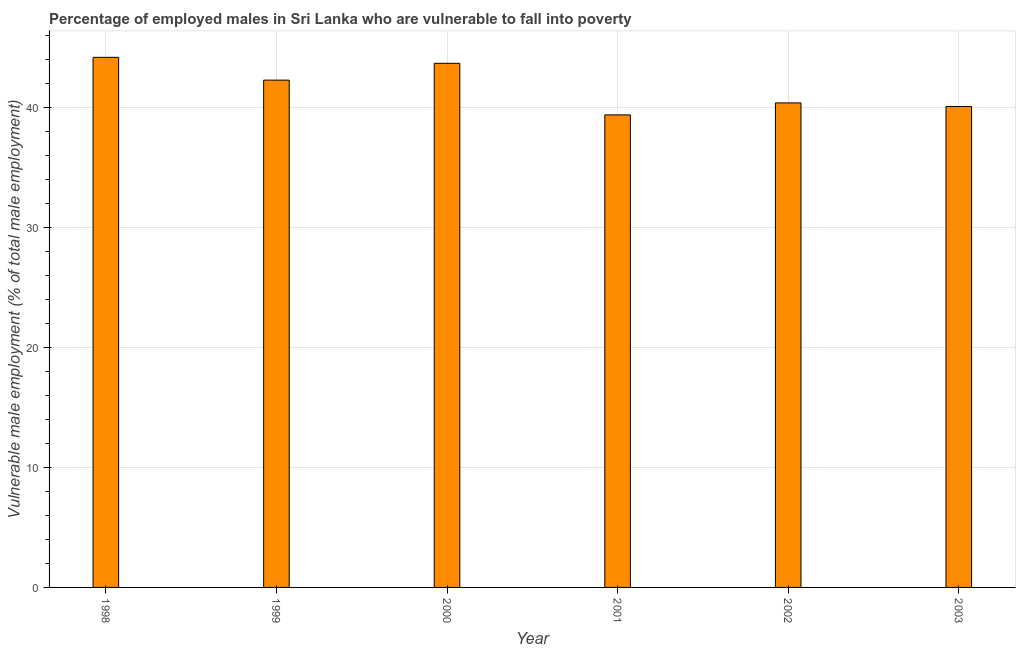Does the graph contain any zero values?
Your response must be concise. No. What is the title of the graph?
Give a very brief answer. Percentage of employed males in Sri Lanka who are vulnerable to fall into poverty. What is the label or title of the Y-axis?
Your answer should be compact. Vulnerable male employment (% of total male employment). What is the percentage of employed males who are vulnerable to fall into poverty in 2002?
Make the answer very short. 40.4. Across all years, what is the maximum percentage of employed males who are vulnerable to fall into poverty?
Make the answer very short. 44.2. Across all years, what is the minimum percentage of employed males who are vulnerable to fall into poverty?
Provide a succinct answer. 39.4. In which year was the percentage of employed males who are vulnerable to fall into poverty maximum?
Your answer should be very brief. 1998. What is the sum of the percentage of employed males who are vulnerable to fall into poverty?
Ensure brevity in your answer.  250.1. What is the average percentage of employed males who are vulnerable to fall into poverty per year?
Offer a very short reply. 41.68. What is the median percentage of employed males who are vulnerable to fall into poverty?
Your response must be concise. 41.35. Is the percentage of employed males who are vulnerable to fall into poverty in 1999 less than that in 2003?
Offer a terse response. No. Is the difference between the percentage of employed males who are vulnerable to fall into poverty in 2000 and 2002 greater than the difference between any two years?
Ensure brevity in your answer.  No. Is the sum of the percentage of employed males who are vulnerable to fall into poverty in 1998 and 2002 greater than the maximum percentage of employed males who are vulnerable to fall into poverty across all years?
Give a very brief answer. Yes. What is the difference between the highest and the lowest percentage of employed males who are vulnerable to fall into poverty?
Make the answer very short. 4.8. In how many years, is the percentage of employed males who are vulnerable to fall into poverty greater than the average percentage of employed males who are vulnerable to fall into poverty taken over all years?
Provide a short and direct response. 3. How many bars are there?
Keep it short and to the point. 6. Are all the bars in the graph horizontal?
Keep it short and to the point. No. How many years are there in the graph?
Provide a succinct answer. 6. What is the difference between two consecutive major ticks on the Y-axis?
Make the answer very short. 10. Are the values on the major ticks of Y-axis written in scientific E-notation?
Provide a short and direct response. No. What is the Vulnerable male employment (% of total male employment) of 1998?
Offer a very short reply. 44.2. What is the Vulnerable male employment (% of total male employment) of 1999?
Your answer should be very brief. 42.3. What is the Vulnerable male employment (% of total male employment) of 2000?
Your response must be concise. 43.7. What is the Vulnerable male employment (% of total male employment) of 2001?
Your answer should be compact. 39.4. What is the Vulnerable male employment (% of total male employment) of 2002?
Keep it short and to the point. 40.4. What is the Vulnerable male employment (% of total male employment) in 2003?
Give a very brief answer. 40.1. What is the difference between the Vulnerable male employment (% of total male employment) in 1998 and 1999?
Keep it short and to the point. 1.9. What is the difference between the Vulnerable male employment (% of total male employment) in 1998 and 2000?
Your response must be concise. 0.5. What is the difference between the Vulnerable male employment (% of total male employment) in 1998 and 2001?
Provide a short and direct response. 4.8. What is the difference between the Vulnerable male employment (% of total male employment) in 1998 and 2002?
Offer a terse response. 3.8. What is the difference between the Vulnerable male employment (% of total male employment) in 1998 and 2003?
Keep it short and to the point. 4.1. What is the difference between the Vulnerable male employment (% of total male employment) in 1999 and 2003?
Your answer should be compact. 2.2. What is the difference between the Vulnerable male employment (% of total male employment) in 2000 and 2002?
Provide a short and direct response. 3.3. What is the difference between the Vulnerable male employment (% of total male employment) in 2002 and 2003?
Your answer should be compact. 0.3. What is the ratio of the Vulnerable male employment (% of total male employment) in 1998 to that in 1999?
Provide a succinct answer. 1.04. What is the ratio of the Vulnerable male employment (% of total male employment) in 1998 to that in 2001?
Offer a terse response. 1.12. What is the ratio of the Vulnerable male employment (% of total male employment) in 1998 to that in 2002?
Provide a succinct answer. 1.09. What is the ratio of the Vulnerable male employment (% of total male employment) in 1998 to that in 2003?
Your response must be concise. 1.1. What is the ratio of the Vulnerable male employment (% of total male employment) in 1999 to that in 2000?
Give a very brief answer. 0.97. What is the ratio of the Vulnerable male employment (% of total male employment) in 1999 to that in 2001?
Ensure brevity in your answer.  1.07. What is the ratio of the Vulnerable male employment (% of total male employment) in 1999 to that in 2002?
Give a very brief answer. 1.05. What is the ratio of the Vulnerable male employment (% of total male employment) in 1999 to that in 2003?
Offer a very short reply. 1.05. What is the ratio of the Vulnerable male employment (% of total male employment) in 2000 to that in 2001?
Keep it short and to the point. 1.11. What is the ratio of the Vulnerable male employment (% of total male employment) in 2000 to that in 2002?
Your answer should be very brief. 1.08. What is the ratio of the Vulnerable male employment (% of total male employment) in 2000 to that in 2003?
Your response must be concise. 1.09. What is the ratio of the Vulnerable male employment (% of total male employment) in 2001 to that in 2002?
Your answer should be compact. 0.97. 